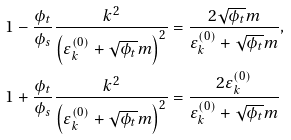Convert formula to latex. <formula><loc_0><loc_0><loc_500><loc_500>1 - \frac { \phi _ { t } } { \phi _ { s } } \frac { k ^ { 2 } } { \left ( \varepsilon ^ { ( 0 ) } _ { k } + \sqrt { \phi _ { t } } m \right ) ^ { 2 } } & = \frac { 2 \sqrt { \phi _ { t } } m } { \varepsilon ^ { ( 0 ) } _ { k } + \sqrt { \phi _ { t } } m } , \\ 1 + \frac { \phi _ { t } } { \phi _ { s } } \frac { k ^ { 2 } } { \left ( \varepsilon ^ { ( 0 ) } _ { k } + \sqrt { \phi _ { t } } m \right ) ^ { 2 } } & = \frac { 2 \varepsilon ^ { ( 0 ) } _ { k } } { \varepsilon ^ { ( 0 ) } _ { k } + \sqrt { \phi _ { t } } m }</formula> 